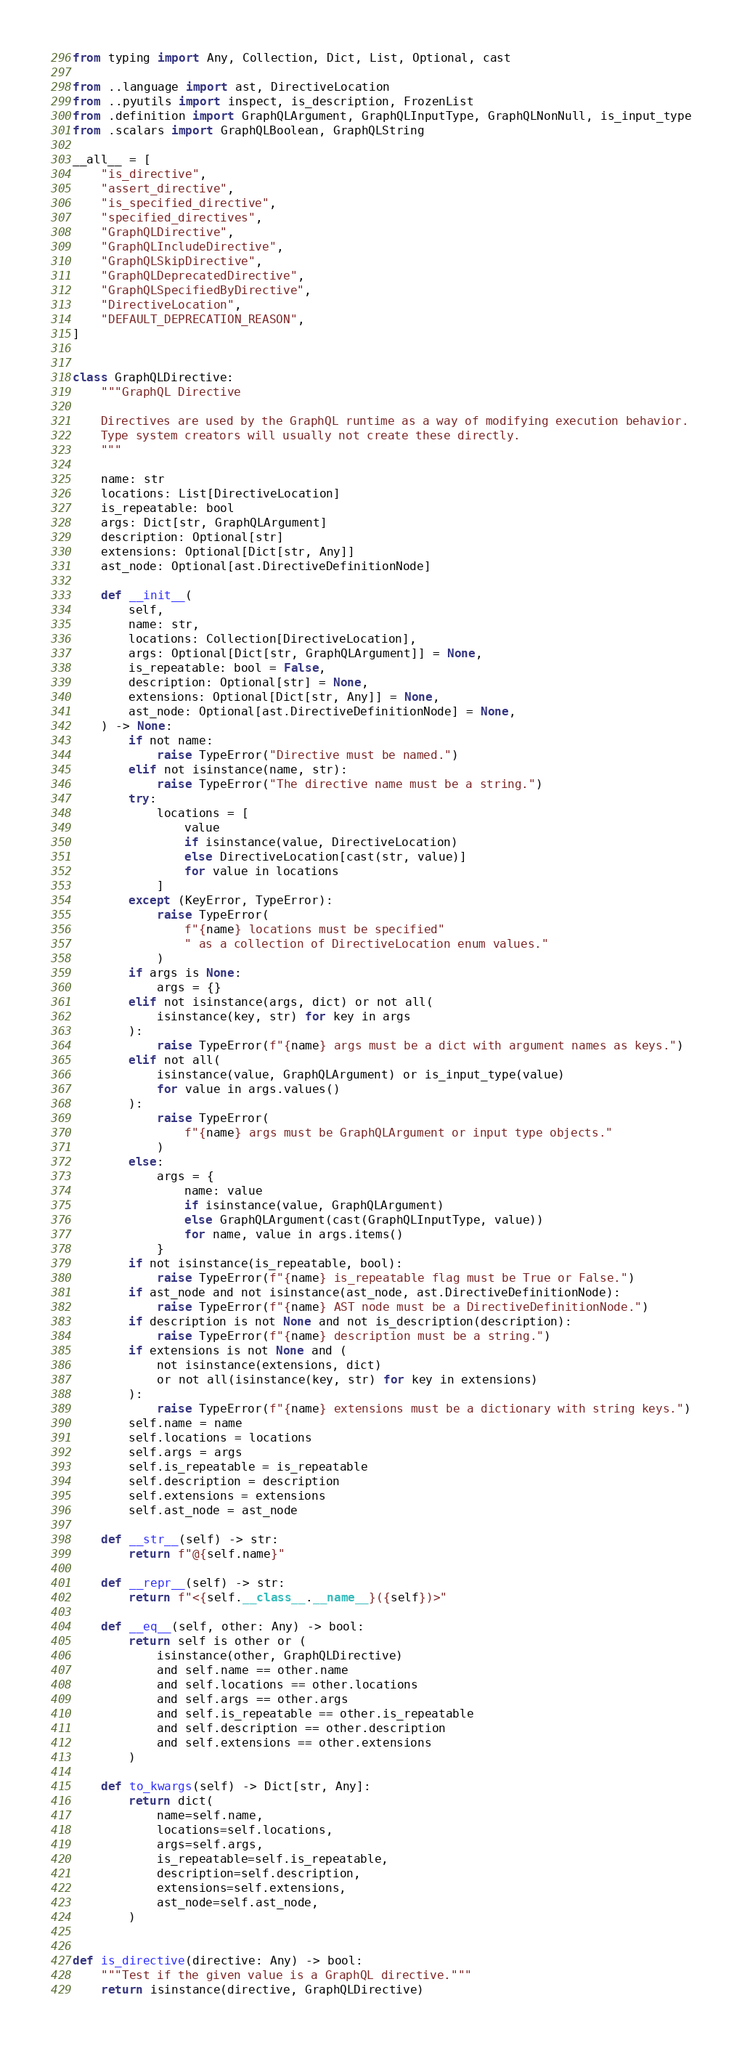<code> <loc_0><loc_0><loc_500><loc_500><_Python_>from typing import Any, Collection, Dict, List, Optional, cast

from ..language import ast, DirectiveLocation
from ..pyutils import inspect, is_description, FrozenList
from .definition import GraphQLArgument, GraphQLInputType, GraphQLNonNull, is_input_type
from .scalars import GraphQLBoolean, GraphQLString

__all__ = [
    "is_directive",
    "assert_directive",
    "is_specified_directive",
    "specified_directives",
    "GraphQLDirective",
    "GraphQLIncludeDirective",
    "GraphQLSkipDirective",
    "GraphQLDeprecatedDirective",
    "GraphQLSpecifiedByDirective",
    "DirectiveLocation",
    "DEFAULT_DEPRECATION_REASON",
]


class GraphQLDirective:
    """GraphQL Directive

    Directives are used by the GraphQL runtime as a way of modifying execution behavior.
    Type system creators will usually not create these directly.
    """

    name: str
    locations: List[DirectiveLocation]
    is_repeatable: bool
    args: Dict[str, GraphQLArgument]
    description: Optional[str]
    extensions: Optional[Dict[str, Any]]
    ast_node: Optional[ast.DirectiveDefinitionNode]

    def __init__(
        self,
        name: str,
        locations: Collection[DirectiveLocation],
        args: Optional[Dict[str, GraphQLArgument]] = None,
        is_repeatable: bool = False,
        description: Optional[str] = None,
        extensions: Optional[Dict[str, Any]] = None,
        ast_node: Optional[ast.DirectiveDefinitionNode] = None,
    ) -> None:
        if not name:
            raise TypeError("Directive must be named.")
        elif not isinstance(name, str):
            raise TypeError("The directive name must be a string.")
        try:
            locations = [
                value
                if isinstance(value, DirectiveLocation)
                else DirectiveLocation[cast(str, value)]
                for value in locations
            ]
        except (KeyError, TypeError):
            raise TypeError(
                f"{name} locations must be specified"
                " as a collection of DirectiveLocation enum values."
            )
        if args is None:
            args = {}
        elif not isinstance(args, dict) or not all(
            isinstance(key, str) for key in args
        ):
            raise TypeError(f"{name} args must be a dict with argument names as keys.")
        elif not all(
            isinstance(value, GraphQLArgument) or is_input_type(value)
            for value in args.values()
        ):
            raise TypeError(
                f"{name} args must be GraphQLArgument or input type objects."
            )
        else:
            args = {
                name: value
                if isinstance(value, GraphQLArgument)
                else GraphQLArgument(cast(GraphQLInputType, value))
                for name, value in args.items()
            }
        if not isinstance(is_repeatable, bool):
            raise TypeError(f"{name} is_repeatable flag must be True or False.")
        if ast_node and not isinstance(ast_node, ast.DirectiveDefinitionNode):
            raise TypeError(f"{name} AST node must be a DirectiveDefinitionNode.")
        if description is not None and not is_description(description):
            raise TypeError(f"{name} description must be a string.")
        if extensions is not None and (
            not isinstance(extensions, dict)
            or not all(isinstance(key, str) for key in extensions)
        ):
            raise TypeError(f"{name} extensions must be a dictionary with string keys.")
        self.name = name
        self.locations = locations
        self.args = args
        self.is_repeatable = is_repeatable
        self.description = description
        self.extensions = extensions
        self.ast_node = ast_node

    def __str__(self) -> str:
        return f"@{self.name}"

    def __repr__(self) -> str:
        return f"<{self.__class__.__name__}({self})>"

    def __eq__(self, other: Any) -> bool:
        return self is other or (
            isinstance(other, GraphQLDirective)
            and self.name == other.name
            and self.locations == other.locations
            and self.args == other.args
            and self.is_repeatable == other.is_repeatable
            and self.description == other.description
            and self.extensions == other.extensions
        )

    def to_kwargs(self) -> Dict[str, Any]:
        return dict(
            name=self.name,
            locations=self.locations,
            args=self.args,
            is_repeatable=self.is_repeatable,
            description=self.description,
            extensions=self.extensions,
            ast_node=self.ast_node,
        )


def is_directive(directive: Any) -> bool:
    """Test if the given value is a GraphQL directive."""
    return isinstance(directive, GraphQLDirective)

</code> 